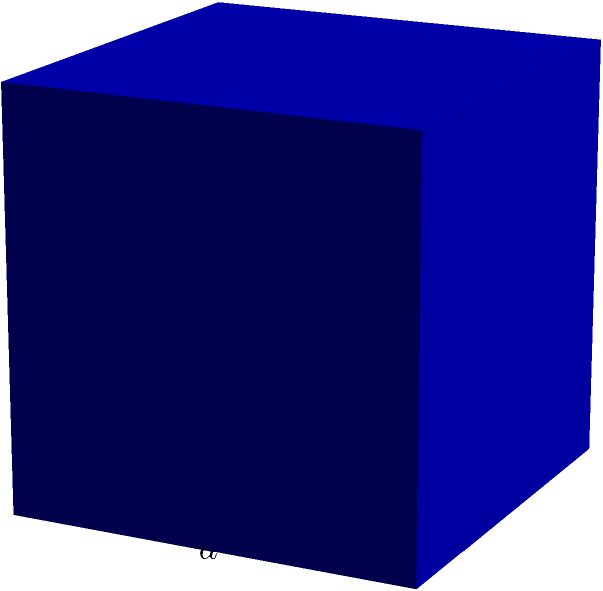A community center is helping families relocate and needs to calculate the total surface area of cubic moving boxes. If each box has a side length of $a$ units, and the community needs 50 such boxes, what is the total surface area of all the boxes combined? To solve this problem, let's follow these steps:

1. Calculate the surface area of one cubic box:
   - A cube has 6 square faces
   - Each face has an area of $a^2$
   - Surface area of one box = $6a^2$

2. Calculate the total surface area for all 50 boxes:
   - Total surface area = Surface area of one box × Number of boxes
   - Total surface area = $6a^2 \times 50$
   - Total surface area = $300a^2$

Therefore, the total surface area of all 50 cubic moving boxes is $300a^2$ square units.
Answer: $300a^2$ square units 